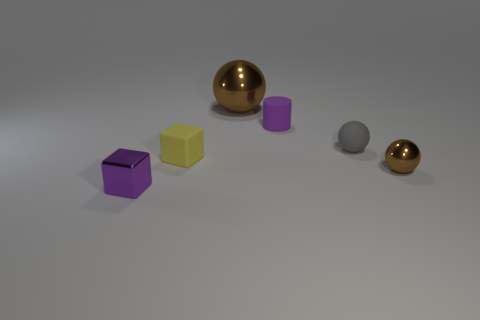Subtract all gray spheres. Subtract all brown blocks. How many spheres are left? 2 Add 1 small gray blocks. How many objects exist? 7 Subtract all cubes. How many objects are left? 4 Add 1 rubber balls. How many rubber balls are left? 2 Add 1 metal blocks. How many metal blocks exist? 2 Subtract 0 brown cubes. How many objects are left? 6 Subtract all tiny yellow matte cubes. Subtract all purple cubes. How many objects are left? 4 